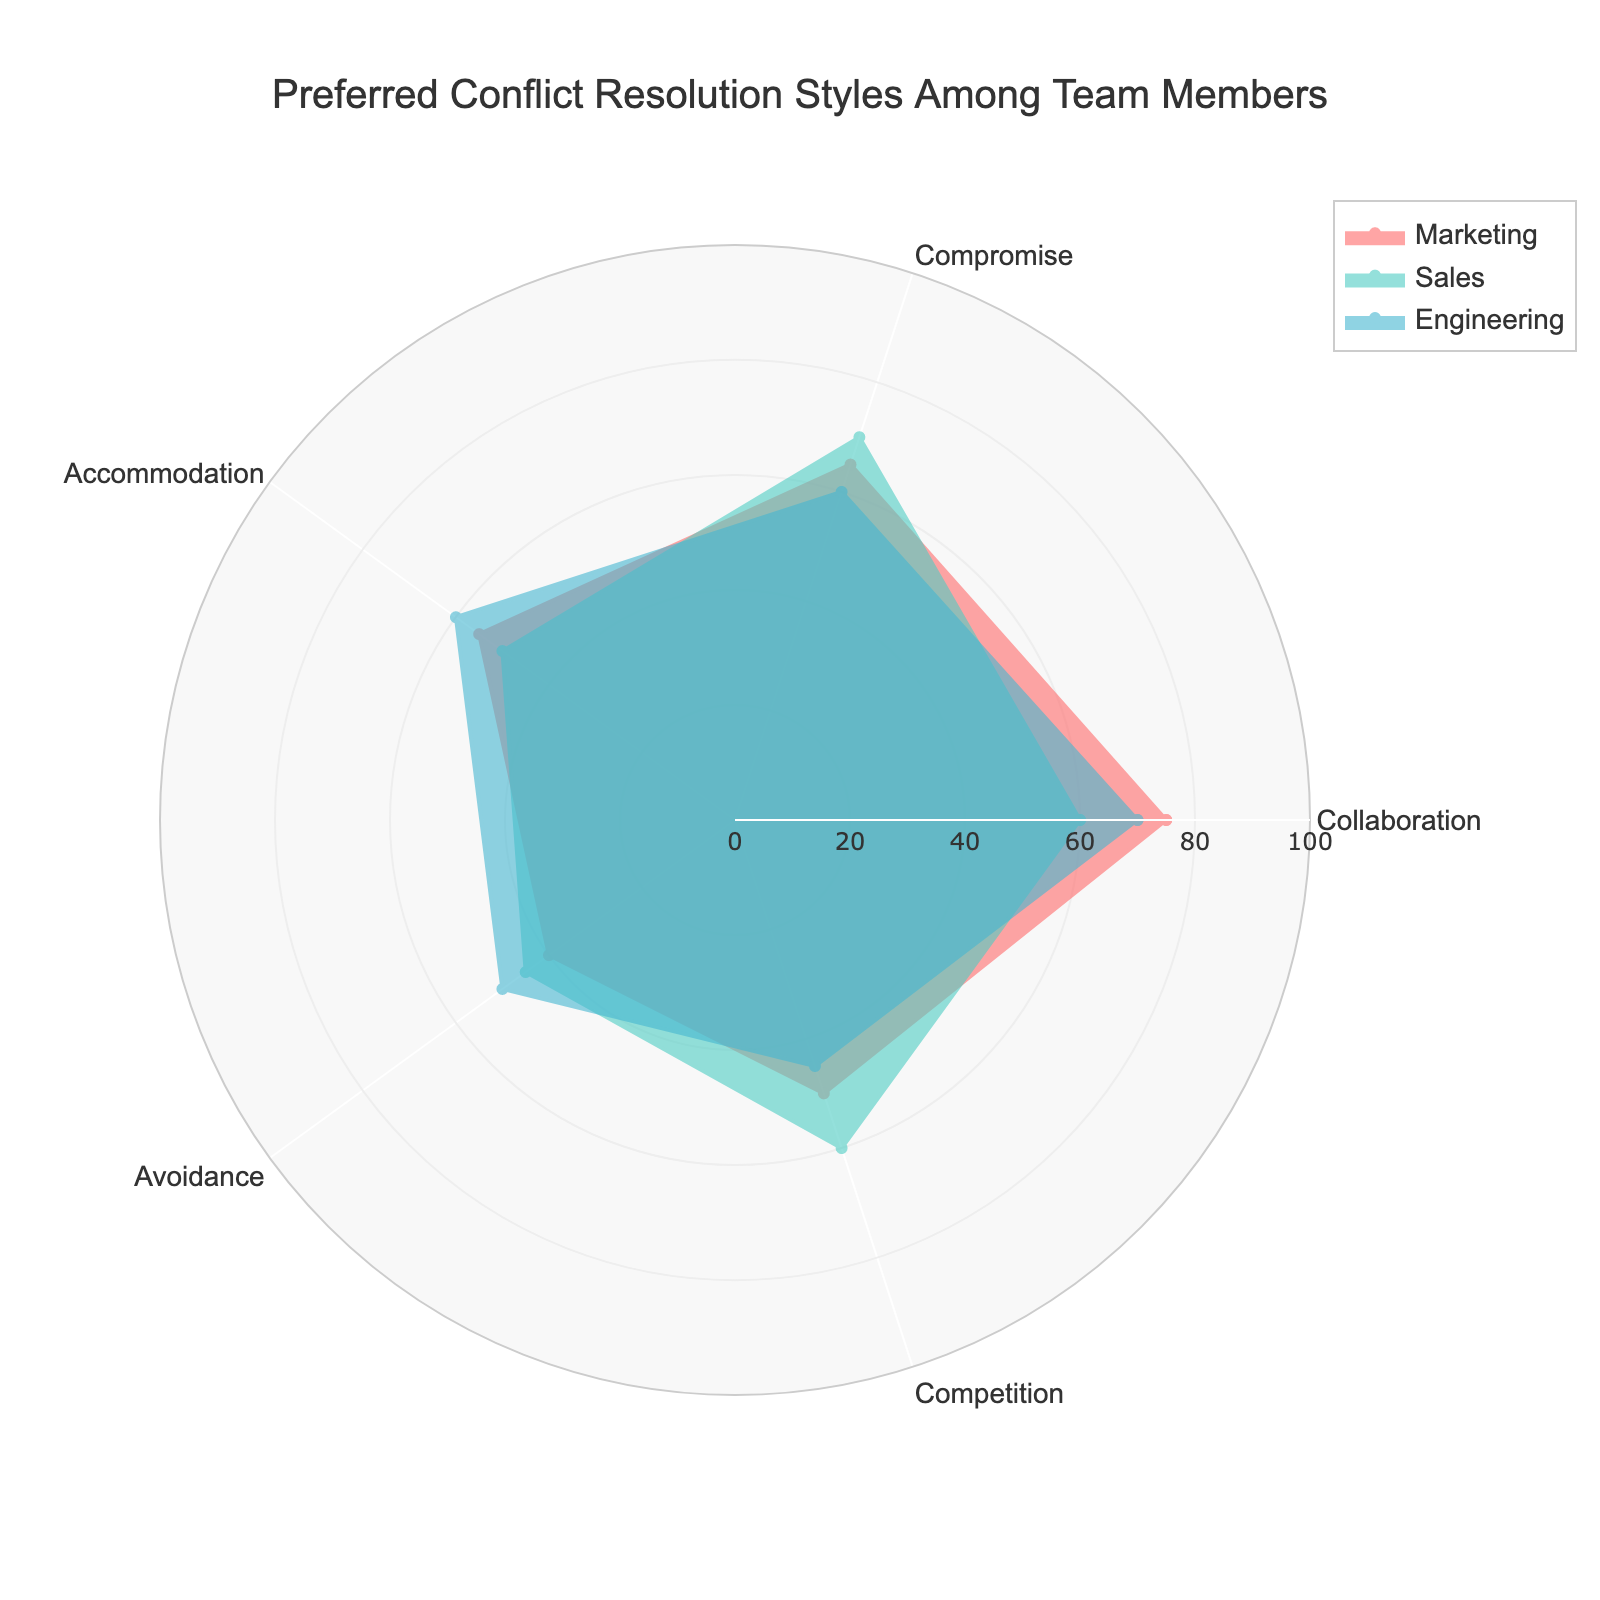What's the title of the radar chart? The title is prominently displayed at the top center of the chart. It reads "Preferred Conflict Resolution Styles Among Team Members".
Answer: Preferred Conflict Resolution Styles Among Team Members How many groups are compared in the chart? Looking at the legend and the data represented, there are three groups compared in the chart: Marketing, Sales, and Engineering.
Answer: Three Which group has the highest value in Collaboration? By comparing the values in the Collaboration category, Marketing has the highest value with 75.
Answer: Marketing What is the difference in the Competition values between Sales and Engineering? The value for Competition in Sales is 60, and in Engineering, it is 45. The difference is calculated as 60 - 45 = 15.
Answer: 15 Which group has the lowest value in Avoidance? By examining the Avoidance data points, Engineering has the highest value with 50 and Sales has a value of 45. Marketing has the lowest value with 40.
Answer: Marketing In which category does Marketing show the highest value compared to Sales and Engineering? By visually inspecting each category, Marketing shows the highest value in Collaboration.
Answer: Collaboration What is the average value of Sales across all categories? Sum the values for Sales (60, 70, 50, 45, 60) to get 285. Divide by the number of categories (5) for an average: 285/5 = 57.
Answer: 57 What are the Collaboration values for all three groups? By checking the Collaboration axis for each group, the values are: Marketing 75, Sales 60, Engineering 70.
Answer: 75 for Marketing, 60 for Sales, 70 for Engineering Which group has the most balanced profile across all categories? A balanced profile would have the least variation across all categories. Engineering has values relatively close to each other (70, 60, 60, 50, 45).
Answer: Engineering Is the Sales group's value in Compromise larger or smaller than in Accommodation? By comparing the two categories: Compromise has a value of 70, while Accommodation has a value of 50, hence Compromise is larger.
Answer: Larger 